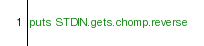Convert code to text. <code><loc_0><loc_0><loc_500><loc_500><_Ruby_>puts STDIN.gets.chomp.reverse</code> 